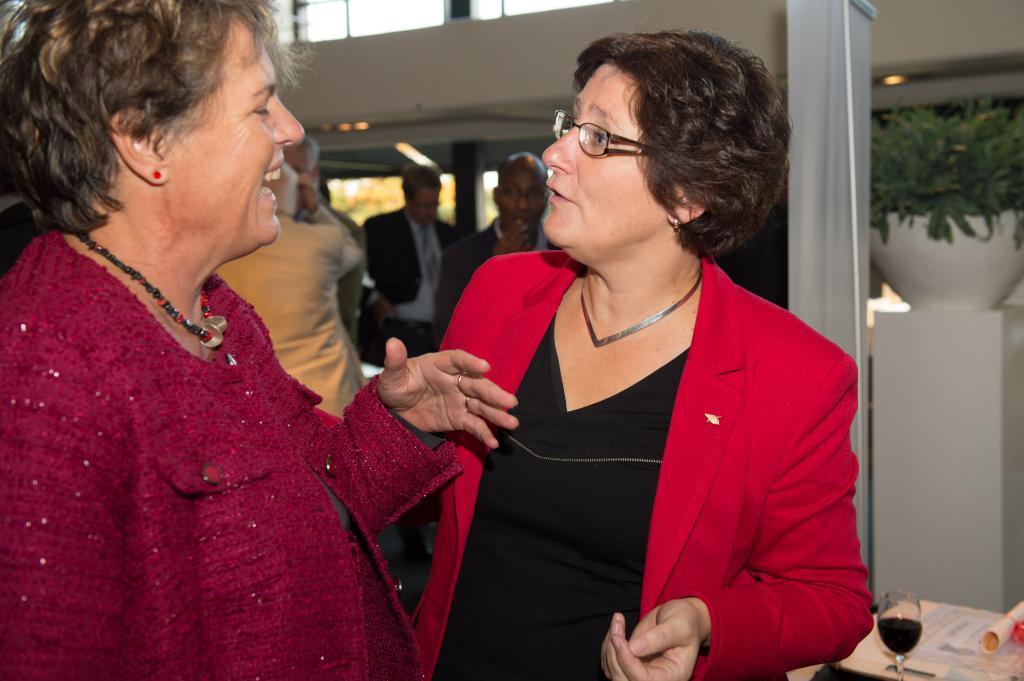How would you summarize this image in a sentence or two? In this image we can see two ladies standing and smiling. In the background there are people and there is a banner. At the bottom there is a table and we can see a wine glass and papers placed on the table. There is a houseplant. 